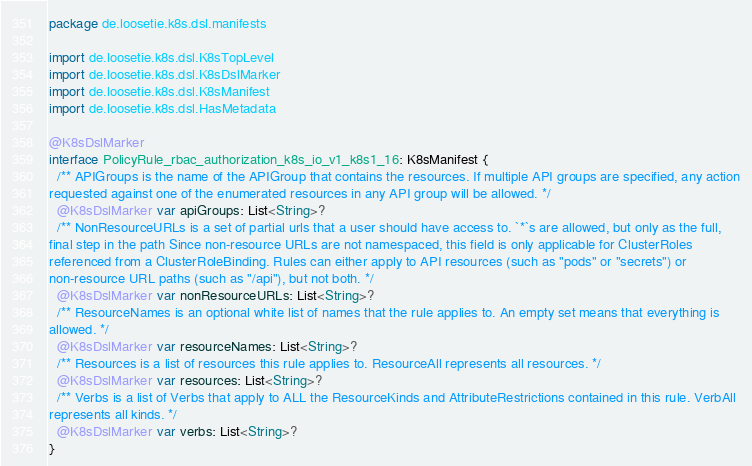Convert code to text. <code><loc_0><loc_0><loc_500><loc_500><_Kotlin_>package de.loosetie.k8s.dsl.manifests

import de.loosetie.k8s.dsl.K8sTopLevel
import de.loosetie.k8s.dsl.K8sDslMarker
import de.loosetie.k8s.dsl.K8sManifest
import de.loosetie.k8s.dsl.HasMetadata
      
@K8sDslMarker
interface PolicyRule_rbac_authorization_k8s_io_v1_k8s1_16: K8sManifest {
  /** APIGroups is the name of the APIGroup that contains the resources. If multiple API groups are specified, any action
requested against one of the enumerated resources in any API group will be allowed. */
  @K8sDslMarker var apiGroups: List<String>?
  /** NonResourceURLs is a set of partial urls that a user should have access to. `*`s are allowed, but only as the full,
final step in the path Since non-resource URLs are not namespaced, this field is only applicable for ClusterRoles
referenced from a ClusterRoleBinding. Rules can either apply to API resources (such as "pods" or "secrets") or
non-resource URL paths (such as "/api"), but not both. */
  @K8sDslMarker var nonResourceURLs: List<String>?
  /** ResourceNames is an optional white list of names that the rule applies to. An empty set means that everything is
allowed. */
  @K8sDslMarker var resourceNames: List<String>?
  /** Resources is a list of resources this rule applies to. ResourceAll represents all resources. */
  @K8sDslMarker var resources: List<String>?
  /** Verbs is a list of Verbs that apply to ALL the ResourceKinds and AttributeRestrictions contained in this rule. VerbAll
represents all kinds. */
  @K8sDslMarker var verbs: List<String>?
}      </code> 